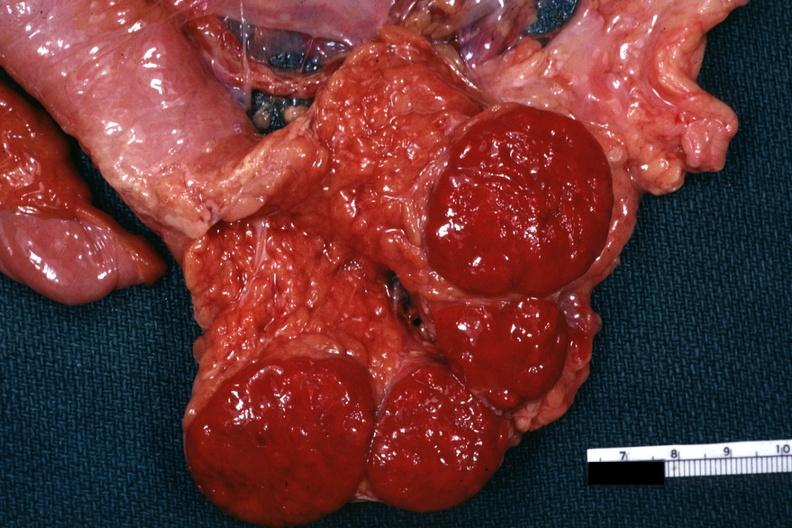s hematologic present?
Answer the question using a single word or phrase. Yes 